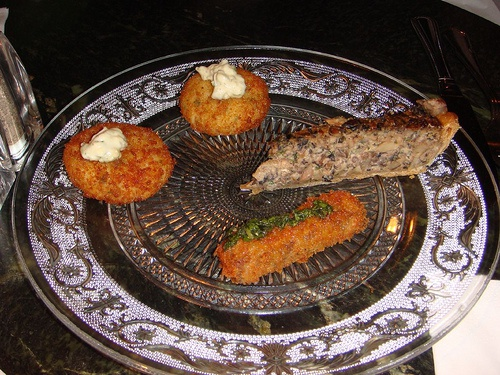Describe the objects in this image and their specific colors. I can see cake in black, tan, gray, and maroon tones and donut in black, red, tan, maroon, and orange tones in this image. 